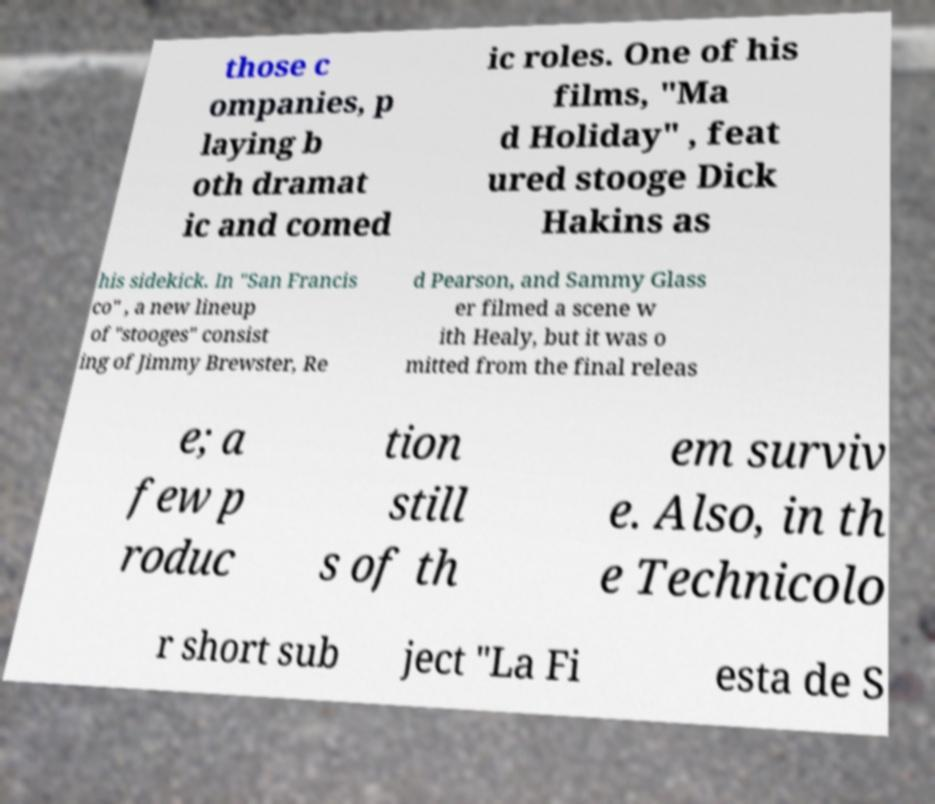Could you extract and type out the text from this image? those c ompanies, p laying b oth dramat ic and comed ic roles. One of his films, "Ma d Holiday" , feat ured stooge Dick Hakins as his sidekick. In "San Francis co" , a new lineup of "stooges" consist ing of Jimmy Brewster, Re d Pearson, and Sammy Glass er filmed a scene w ith Healy, but it was o mitted from the final releas e; a few p roduc tion still s of th em surviv e. Also, in th e Technicolo r short sub ject "La Fi esta de S 